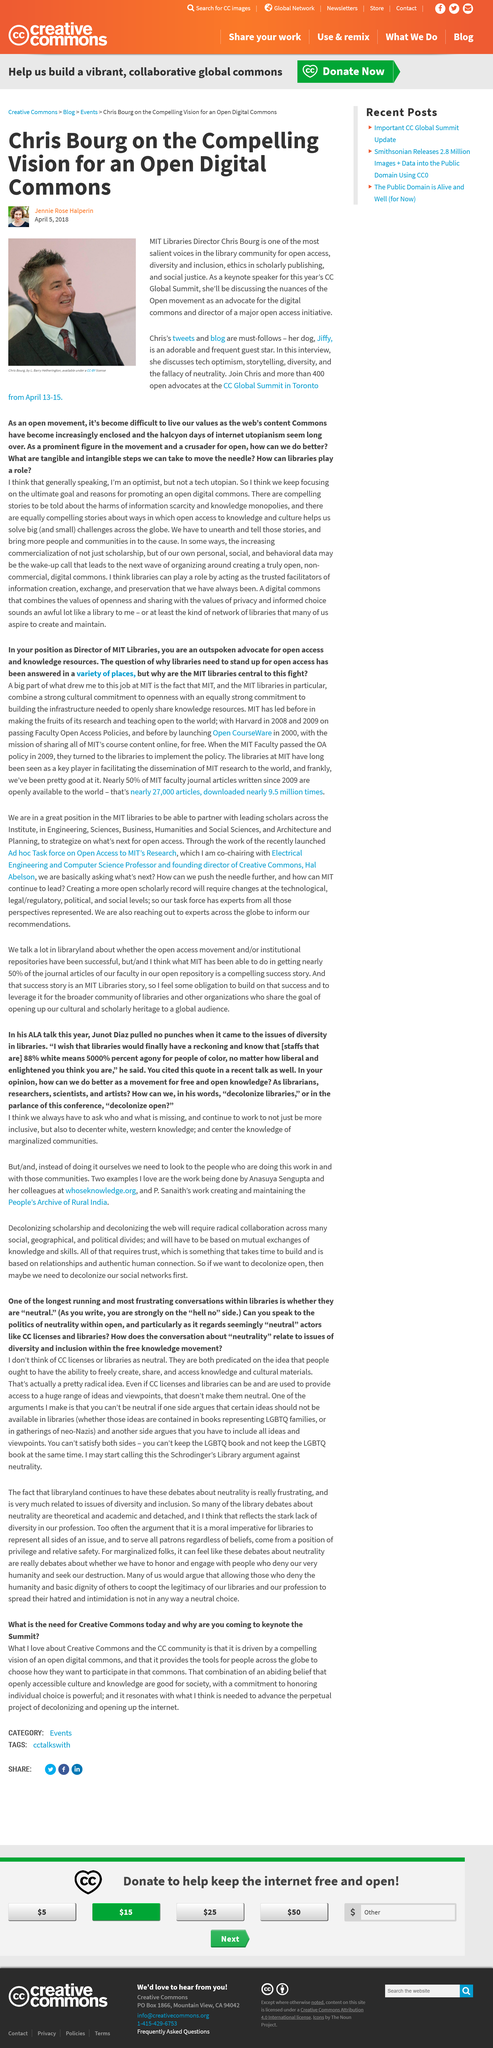Indicate a few pertinent items in this graphic. The keynote speaker for this year's CC Global Summit is Chris Bourg. Jennie Rose Halperin is the writer of the above article. Chris Bourg has a pet dog named Jiffy. 